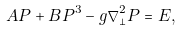<formula> <loc_0><loc_0><loc_500><loc_500>A P + B P ^ { 3 } - g \nabla _ { \perp } ^ { 2 } P = E ,</formula> 